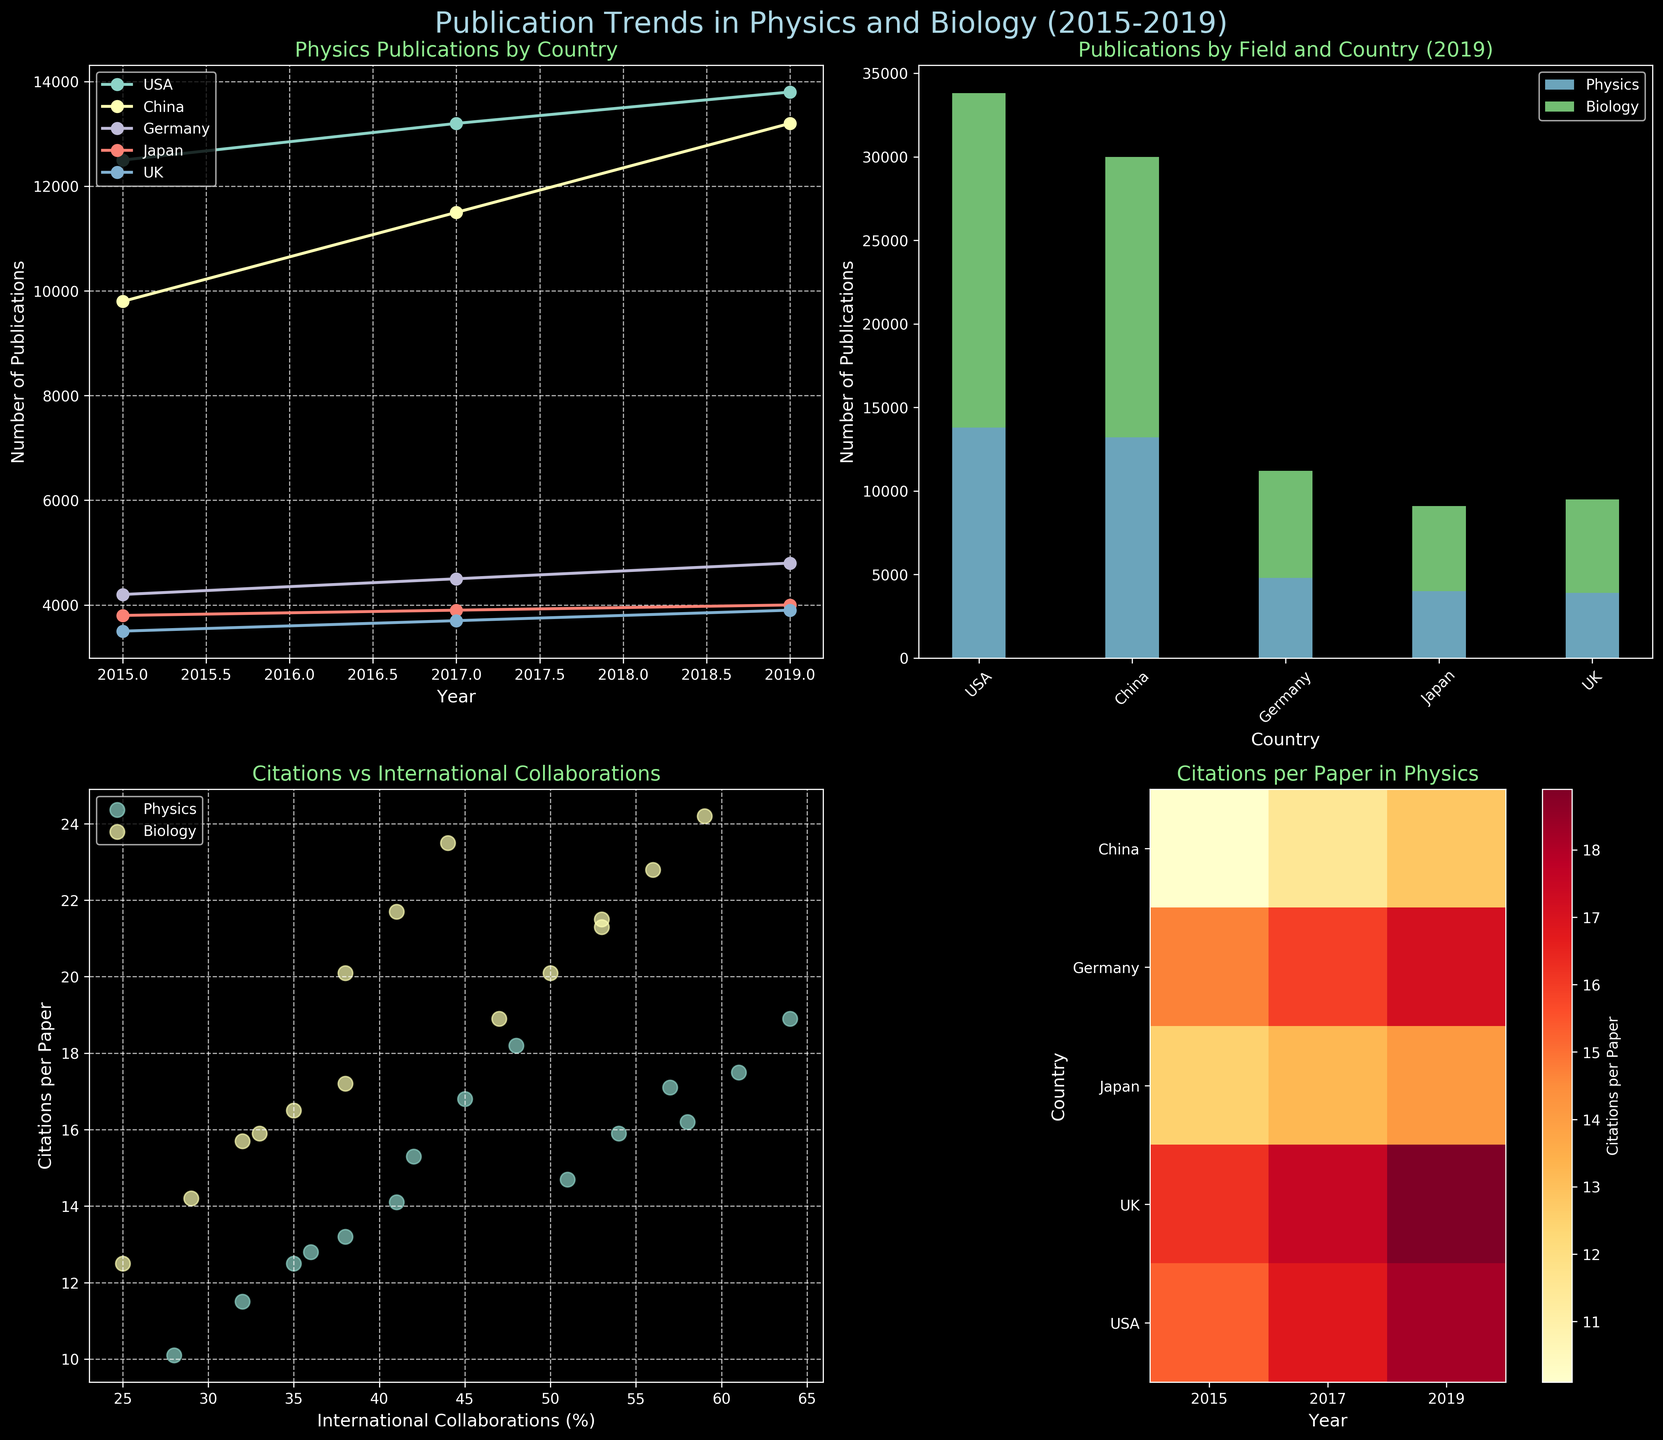What is the total number of Physics publications for the USA and China in 2019? To find the total number of Physics publications for the USA and China in 2019, we refer to the line plot of Publications over time. The number of publications for the USA in 2019 is 13800, and for China, it is 13200. Adding these numbers together gives 13800 + 13200 = 27000.
Answer: 27000 Which country had the highest number of Biology publications in 2019? In the stacked bar chart of Publications by Field and Country for 2019, we can see that the USA has the highest segment for Biology publications. The height of the Biology portion for the USA is 20000.
Answer: USA What trend can be observed in the citations per paper for the UK from 2015 to 2019 in Physics? Looking at the heatmap of Citations per Paper in Physics, we observe that for the UK, citations per paper increased from 16.2 in 2015 to 17.5 in 2017, and further to 18.9 in 2019. This shows a steady upward trend.
Answer: Increasing Does the scatter plot show any field having a strong positive correlation between international collaborations and citations per paper? By examining the scatter plot, we can see that both Physics and Biology have points that trend upwards as the percentage of international collaborations increases, indicating a positive correlation, but we cannot infer the strength of this correlation directly from the plot.
Answer: Yes How many countries are displayed in the heatmap of citations per paper in Physics? Observing the y-axis of the heatmap, we can count the number of distinct country labels. There are five countries listed: USA, China, Germany, Japan, and UK.
Answer: 5 Which country shows the highest increase in Physics publications from 2015 to 2017? Refer to the line plot for Physics publications; comparing 2015 to 2017, China shows an increase from 9800 to 11500. The increase is 11500 - 9800 = 1700, which is the largest increase among the countries.
Answer: China What is the relationship between citations per paper and international collaborations for Biology papers? By examining the scatter plot, we notice that for Biology papers, as international collaborations increase, citations per paper also tend to increase, suggesting a positive relationship.
Answer: Positive correlation Which country has the smallest number of publications in both Physics and Biology in 2019? In the stacked bar chart for 2019, we observe that Japan has the smallest stacked bar height combining both Physics and Biology publications. In 2019, Japan's Physics publications are 4000, and Biology publications are 5100, resulting in a total of 9100.
Answer: Japan 